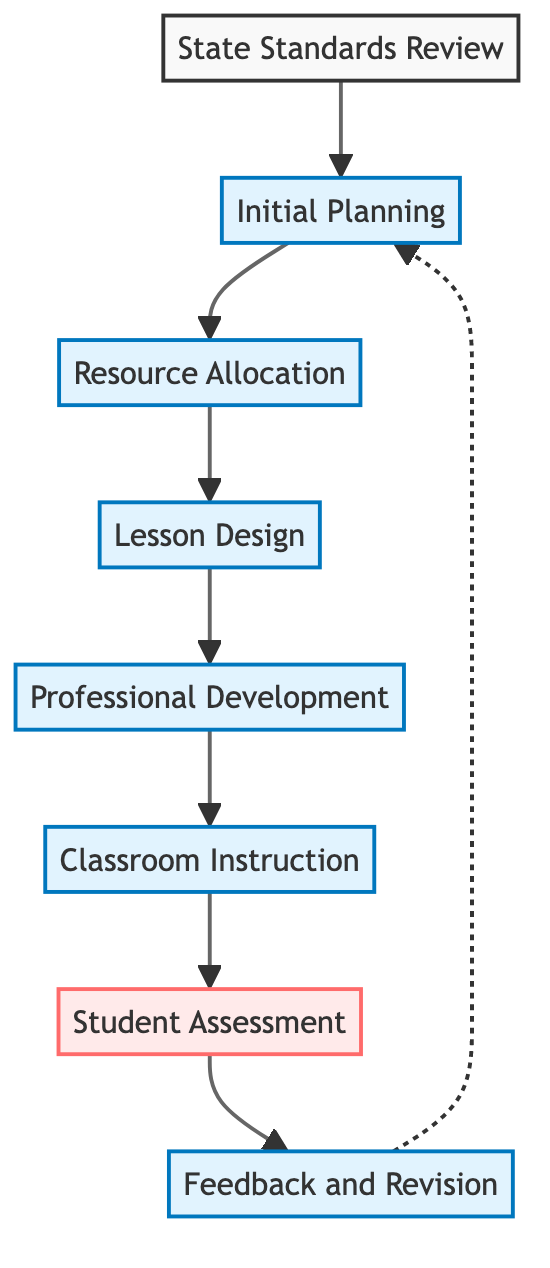What is the first stage in the curriculum development process? The first stage according to the diagram is labeled as "State Standards Review," indicating that reviewing the educational standards is the initial step.
Answer: State Standards Review How many key stages are there in the diagram? The diagram outlines eight key stages in the curriculum development process, as identified by the number of elements present in the flowchart.
Answer: Eight What is the last stage of the curriculum development process? The final stage in the process is "Feedback and Revision," which suggests the importance of refining the curriculum based on collected feedback.
Answer: Feedback and Revision Which stage comes after "Lesson Design"? "Professional Development" follows "Lesson Design" in the flow, focusing on training teachers to implement the newly designed lessons effectively.
Answer: Professional Development What type of node is "Student Assessment"? "Student Assessment" is categorized as an assessment node, indicated by its color and the context that it evaluates student understanding and curriculum effectiveness.
Answer: Assessment Which stage leads back to "Initial Planning"? The "Feedback and Revision" stage connects back to "Initial Planning," suggesting that revisions informed by feedback can necessitate a return to the planning phase.
Answer: Feedback and Revision What does "Resource Allocation" involve? "Resource Allocation" is focused on gathering necessary resources like textbooks, software, and manipulatives for teaching, highlighting its role in preparing for effective instruction.
Answer: Gathering resources How are the stages connected in the diagram? The stages are connected in a linear fashion, except for the feedback loop from "Feedback and Revision" back to "Initial Planning," creating a cyclical relationship for ongoing improvement.
Answer: Linear with a feedback loop What is the purpose of "Professional Development"? The purpose of "Professional Development" is to provide training and workshops, ensuring that teachers are well-equipped to deliver the new curriculum effectively.
Answer: Training teachers 